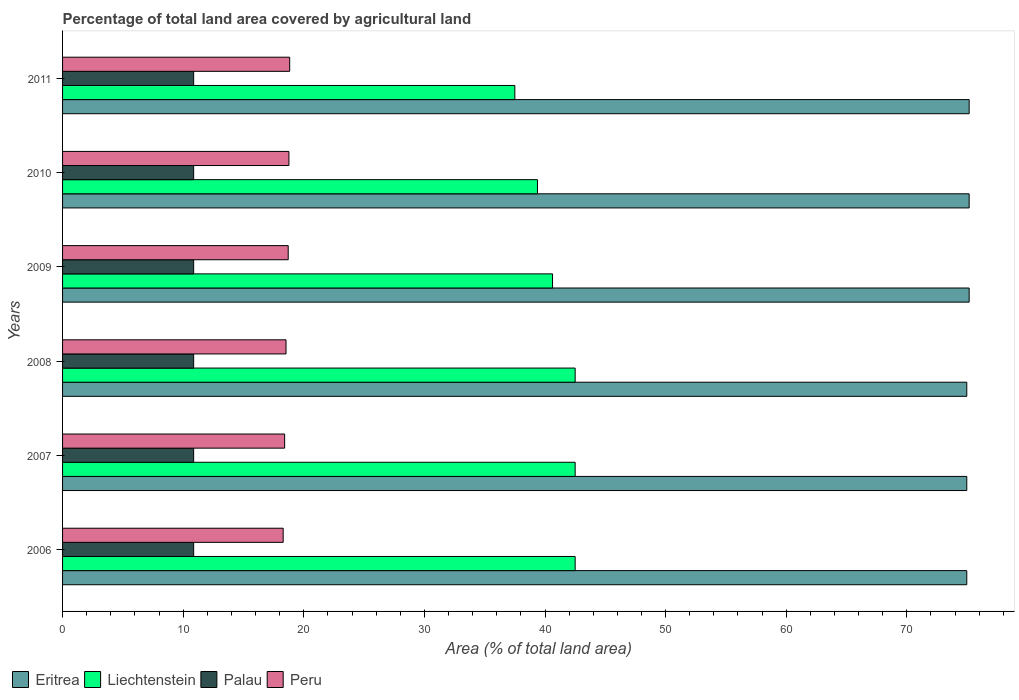Are the number of bars per tick equal to the number of legend labels?
Offer a terse response. Yes. Are the number of bars on each tick of the Y-axis equal?
Keep it short and to the point. Yes. How many bars are there on the 6th tick from the bottom?
Offer a very short reply. 4. What is the label of the 1st group of bars from the top?
Give a very brief answer. 2011. What is the percentage of agricultural land in Peru in 2007?
Provide a succinct answer. 18.41. Across all years, what is the maximum percentage of agricultural land in Eritrea?
Offer a very short reply. 75.17. Across all years, what is the minimum percentage of agricultural land in Peru?
Make the answer very short. 18.29. In which year was the percentage of agricultural land in Palau maximum?
Offer a terse response. 2006. What is the total percentage of agricultural land in Peru in the graph?
Offer a terse response. 111.54. What is the difference between the percentage of agricultural land in Peru in 2006 and that in 2010?
Provide a succinct answer. -0.48. What is the difference between the percentage of agricultural land in Peru in 2010 and the percentage of agricultural land in Palau in 2007?
Provide a succinct answer. 7.9. What is the average percentage of agricultural land in Peru per year?
Provide a succinct answer. 18.59. In the year 2007, what is the difference between the percentage of agricultural land in Eritrea and percentage of agricultural land in Palau?
Make the answer very short. 64.1. What is the ratio of the percentage of agricultural land in Liechtenstein in 2008 to that in 2009?
Ensure brevity in your answer.  1.05. Is the percentage of agricultural land in Peru in 2007 less than that in 2008?
Make the answer very short. Yes. Is the difference between the percentage of agricultural land in Eritrea in 2007 and 2008 greater than the difference between the percentage of agricultural land in Palau in 2007 and 2008?
Give a very brief answer. No. What is the difference between the highest and the second highest percentage of agricultural land in Peru?
Your response must be concise. 0.06. What is the difference between the highest and the lowest percentage of agricultural land in Liechtenstein?
Provide a succinct answer. 5. What does the 1st bar from the top in 2006 represents?
Offer a very short reply. Peru. Are all the bars in the graph horizontal?
Your response must be concise. Yes. How many years are there in the graph?
Offer a terse response. 6. What is the difference between two consecutive major ticks on the X-axis?
Offer a terse response. 10. Does the graph contain any zero values?
Your answer should be compact. No. Does the graph contain grids?
Provide a succinct answer. No. Where does the legend appear in the graph?
Ensure brevity in your answer.  Bottom left. What is the title of the graph?
Your response must be concise. Percentage of total land area covered by agricultural land. What is the label or title of the X-axis?
Keep it short and to the point. Area (% of total land area). What is the label or title of the Y-axis?
Give a very brief answer. Years. What is the Area (% of total land area) of Eritrea in 2006?
Give a very brief answer. 74.97. What is the Area (% of total land area) in Liechtenstein in 2006?
Your answer should be compact. 42.5. What is the Area (% of total land area) of Palau in 2006?
Make the answer very short. 10.87. What is the Area (% of total land area) of Peru in 2006?
Ensure brevity in your answer.  18.29. What is the Area (% of total land area) in Eritrea in 2007?
Your answer should be very brief. 74.97. What is the Area (% of total land area) in Liechtenstein in 2007?
Make the answer very short. 42.5. What is the Area (% of total land area) in Palau in 2007?
Provide a succinct answer. 10.87. What is the Area (% of total land area) of Peru in 2007?
Your answer should be compact. 18.41. What is the Area (% of total land area) in Eritrea in 2008?
Ensure brevity in your answer.  74.97. What is the Area (% of total land area) in Liechtenstein in 2008?
Make the answer very short. 42.5. What is the Area (% of total land area) in Palau in 2008?
Offer a terse response. 10.87. What is the Area (% of total land area) in Peru in 2008?
Keep it short and to the point. 18.53. What is the Area (% of total land area) of Eritrea in 2009?
Provide a short and direct response. 75.17. What is the Area (% of total land area) in Liechtenstein in 2009?
Offer a very short reply. 40.62. What is the Area (% of total land area) in Palau in 2009?
Your response must be concise. 10.87. What is the Area (% of total land area) in Peru in 2009?
Your response must be concise. 18.71. What is the Area (% of total land area) in Eritrea in 2010?
Ensure brevity in your answer.  75.17. What is the Area (% of total land area) in Liechtenstein in 2010?
Your answer should be very brief. 39.38. What is the Area (% of total land area) of Palau in 2010?
Provide a succinct answer. 10.87. What is the Area (% of total land area) of Peru in 2010?
Ensure brevity in your answer.  18.77. What is the Area (% of total land area) of Eritrea in 2011?
Give a very brief answer. 75.17. What is the Area (% of total land area) in Liechtenstein in 2011?
Offer a very short reply. 37.5. What is the Area (% of total land area) of Palau in 2011?
Keep it short and to the point. 10.87. What is the Area (% of total land area) in Peru in 2011?
Give a very brief answer. 18.83. Across all years, what is the maximum Area (% of total land area) in Eritrea?
Offer a terse response. 75.17. Across all years, what is the maximum Area (% of total land area) in Liechtenstein?
Provide a succinct answer. 42.5. Across all years, what is the maximum Area (% of total land area) in Palau?
Provide a short and direct response. 10.87. Across all years, what is the maximum Area (% of total land area) in Peru?
Offer a very short reply. 18.83. Across all years, what is the minimum Area (% of total land area) in Eritrea?
Provide a succinct answer. 74.97. Across all years, what is the minimum Area (% of total land area) in Liechtenstein?
Provide a succinct answer. 37.5. Across all years, what is the minimum Area (% of total land area) in Palau?
Offer a terse response. 10.87. Across all years, what is the minimum Area (% of total land area) in Peru?
Keep it short and to the point. 18.29. What is the total Area (% of total land area) of Eritrea in the graph?
Keep it short and to the point. 450.42. What is the total Area (% of total land area) of Liechtenstein in the graph?
Provide a succinct answer. 245. What is the total Area (% of total land area) of Palau in the graph?
Ensure brevity in your answer.  65.22. What is the total Area (% of total land area) in Peru in the graph?
Offer a terse response. 111.54. What is the difference between the Area (% of total land area) of Eritrea in 2006 and that in 2007?
Keep it short and to the point. 0. What is the difference between the Area (% of total land area) of Peru in 2006 and that in 2007?
Offer a terse response. -0.12. What is the difference between the Area (% of total land area) of Liechtenstein in 2006 and that in 2008?
Make the answer very short. 0. What is the difference between the Area (% of total land area) in Palau in 2006 and that in 2008?
Your answer should be very brief. 0. What is the difference between the Area (% of total land area) of Peru in 2006 and that in 2008?
Ensure brevity in your answer.  -0.24. What is the difference between the Area (% of total land area) of Eritrea in 2006 and that in 2009?
Offer a very short reply. -0.2. What is the difference between the Area (% of total land area) of Liechtenstein in 2006 and that in 2009?
Keep it short and to the point. 1.88. What is the difference between the Area (% of total land area) of Palau in 2006 and that in 2009?
Make the answer very short. 0. What is the difference between the Area (% of total land area) of Peru in 2006 and that in 2009?
Keep it short and to the point. -0.42. What is the difference between the Area (% of total land area) of Eritrea in 2006 and that in 2010?
Your answer should be very brief. -0.2. What is the difference between the Area (% of total land area) in Liechtenstein in 2006 and that in 2010?
Offer a very short reply. 3.12. What is the difference between the Area (% of total land area) of Palau in 2006 and that in 2010?
Your response must be concise. 0. What is the difference between the Area (% of total land area) in Peru in 2006 and that in 2010?
Your answer should be compact. -0.48. What is the difference between the Area (% of total land area) in Eritrea in 2006 and that in 2011?
Make the answer very short. -0.2. What is the difference between the Area (% of total land area) in Palau in 2006 and that in 2011?
Your answer should be compact. 0. What is the difference between the Area (% of total land area) of Peru in 2006 and that in 2011?
Provide a short and direct response. -0.54. What is the difference between the Area (% of total land area) in Liechtenstein in 2007 and that in 2008?
Provide a short and direct response. 0. What is the difference between the Area (% of total land area) of Palau in 2007 and that in 2008?
Offer a very short reply. 0. What is the difference between the Area (% of total land area) in Peru in 2007 and that in 2008?
Offer a very short reply. -0.11. What is the difference between the Area (% of total land area) in Eritrea in 2007 and that in 2009?
Make the answer very short. -0.2. What is the difference between the Area (% of total land area) of Liechtenstein in 2007 and that in 2009?
Your response must be concise. 1.88. What is the difference between the Area (% of total land area) of Peru in 2007 and that in 2009?
Ensure brevity in your answer.  -0.3. What is the difference between the Area (% of total land area) in Eritrea in 2007 and that in 2010?
Offer a terse response. -0.2. What is the difference between the Area (% of total land area) in Liechtenstein in 2007 and that in 2010?
Keep it short and to the point. 3.12. What is the difference between the Area (% of total land area) in Palau in 2007 and that in 2010?
Provide a succinct answer. 0. What is the difference between the Area (% of total land area) in Peru in 2007 and that in 2010?
Offer a terse response. -0.36. What is the difference between the Area (% of total land area) of Eritrea in 2007 and that in 2011?
Your response must be concise. -0.2. What is the difference between the Area (% of total land area) of Liechtenstein in 2007 and that in 2011?
Your answer should be very brief. 5. What is the difference between the Area (% of total land area) in Peru in 2007 and that in 2011?
Your response must be concise. -0.42. What is the difference between the Area (% of total land area) in Eritrea in 2008 and that in 2009?
Your answer should be very brief. -0.2. What is the difference between the Area (% of total land area) of Liechtenstein in 2008 and that in 2009?
Offer a very short reply. 1.88. What is the difference between the Area (% of total land area) of Peru in 2008 and that in 2009?
Provide a short and direct response. -0.18. What is the difference between the Area (% of total land area) in Eritrea in 2008 and that in 2010?
Ensure brevity in your answer.  -0.2. What is the difference between the Area (% of total land area) of Liechtenstein in 2008 and that in 2010?
Offer a terse response. 3.12. What is the difference between the Area (% of total land area) in Palau in 2008 and that in 2010?
Offer a very short reply. 0. What is the difference between the Area (% of total land area) in Peru in 2008 and that in 2010?
Make the answer very short. -0.24. What is the difference between the Area (% of total land area) of Eritrea in 2008 and that in 2011?
Provide a short and direct response. -0.2. What is the difference between the Area (% of total land area) of Liechtenstein in 2008 and that in 2011?
Give a very brief answer. 5. What is the difference between the Area (% of total land area) of Peru in 2008 and that in 2011?
Your response must be concise. -0.3. What is the difference between the Area (% of total land area) of Liechtenstein in 2009 and that in 2010?
Your answer should be compact. 1.25. What is the difference between the Area (% of total land area) in Peru in 2009 and that in 2010?
Keep it short and to the point. -0.06. What is the difference between the Area (% of total land area) of Eritrea in 2009 and that in 2011?
Ensure brevity in your answer.  0. What is the difference between the Area (% of total land area) of Liechtenstein in 2009 and that in 2011?
Keep it short and to the point. 3.12. What is the difference between the Area (% of total land area) of Peru in 2009 and that in 2011?
Offer a very short reply. -0.12. What is the difference between the Area (% of total land area) of Eritrea in 2010 and that in 2011?
Offer a terse response. 0. What is the difference between the Area (% of total land area) in Liechtenstein in 2010 and that in 2011?
Your response must be concise. 1.88. What is the difference between the Area (% of total land area) of Palau in 2010 and that in 2011?
Keep it short and to the point. 0. What is the difference between the Area (% of total land area) in Peru in 2010 and that in 2011?
Your response must be concise. -0.06. What is the difference between the Area (% of total land area) in Eritrea in 2006 and the Area (% of total land area) in Liechtenstein in 2007?
Offer a very short reply. 32.47. What is the difference between the Area (% of total land area) in Eritrea in 2006 and the Area (% of total land area) in Palau in 2007?
Your answer should be compact. 64.1. What is the difference between the Area (% of total land area) in Eritrea in 2006 and the Area (% of total land area) in Peru in 2007?
Your answer should be very brief. 56.56. What is the difference between the Area (% of total land area) in Liechtenstein in 2006 and the Area (% of total land area) in Palau in 2007?
Offer a terse response. 31.63. What is the difference between the Area (% of total land area) of Liechtenstein in 2006 and the Area (% of total land area) of Peru in 2007?
Ensure brevity in your answer.  24.09. What is the difference between the Area (% of total land area) in Palau in 2006 and the Area (% of total land area) in Peru in 2007?
Ensure brevity in your answer.  -7.54. What is the difference between the Area (% of total land area) in Eritrea in 2006 and the Area (% of total land area) in Liechtenstein in 2008?
Offer a very short reply. 32.47. What is the difference between the Area (% of total land area) in Eritrea in 2006 and the Area (% of total land area) in Palau in 2008?
Make the answer very short. 64.1. What is the difference between the Area (% of total land area) in Eritrea in 2006 and the Area (% of total land area) in Peru in 2008?
Your response must be concise. 56.44. What is the difference between the Area (% of total land area) of Liechtenstein in 2006 and the Area (% of total land area) of Palau in 2008?
Your answer should be compact. 31.63. What is the difference between the Area (% of total land area) in Liechtenstein in 2006 and the Area (% of total land area) in Peru in 2008?
Ensure brevity in your answer.  23.97. What is the difference between the Area (% of total land area) of Palau in 2006 and the Area (% of total land area) of Peru in 2008?
Give a very brief answer. -7.66. What is the difference between the Area (% of total land area) of Eritrea in 2006 and the Area (% of total land area) of Liechtenstein in 2009?
Offer a terse response. 34.35. What is the difference between the Area (% of total land area) of Eritrea in 2006 and the Area (% of total land area) of Palau in 2009?
Your response must be concise. 64.1. What is the difference between the Area (% of total land area) of Eritrea in 2006 and the Area (% of total land area) of Peru in 2009?
Provide a short and direct response. 56.26. What is the difference between the Area (% of total land area) of Liechtenstein in 2006 and the Area (% of total land area) of Palau in 2009?
Make the answer very short. 31.63. What is the difference between the Area (% of total land area) in Liechtenstein in 2006 and the Area (% of total land area) in Peru in 2009?
Your response must be concise. 23.79. What is the difference between the Area (% of total land area) in Palau in 2006 and the Area (% of total land area) in Peru in 2009?
Provide a short and direct response. -7.84. What is the difference between the Area (% of total land area) in Eritrea in 2006 and the Area (% of total land area) in Liechtenstein in 2010?
Your answer should be compact. 35.6. What is the difference between the Area (% of total land area) in Eritrea in 2006 and the Area (% of total land area) in Palau in 2010?
Your answer should be compact. 64.1. What is the difference between the Area (% of total land area) of Eritrea in 2006 and the Area (% of total land area) of Peru in 2010?
Your response must be concise. 56.2. What is the difference between the Area (% of total land area) of Liechtenstein in 2006 and the Area (% of total land area) of Palau in 2010?
Your answer should be compact. 31.63. What is the difference between the Area (% of total land area) in Liechtenstein in 2006 and the Area (% of total land area) in Peru in 2010?
Offer a very short reply. 23.73. What is the difference between the Area (% of total land area) in Palau in 2006 and the Area (% of total land area) in Peru in 2010?
Make the answer very short. -7.9. What is the difference between the Area (% of total land area) in Eritrea in 2006 and the Area (% of total land area) in Liechtenstein in 2011?
Your response must be concise. 37.47. What is the difference between the Area (% of total land area) of Eritrea in 2006 and the Area (% of total land area) of Palau in 2011?
Offer a very short reply. 64.1. What is the difference between the Area (% of total land area) of Eritrea in 2006 and the Area (% of total land area) of Peru in 2011?
Provide a short and direct response. 56.14. What is the difference between the Area (% of total land area) in Liechtenstein in 2006 and the Area (% of total land area) in Palau in 2011?
Your response must be concise. 31.63. What is the difference between the Area (% of total land area) of Liechtenstein in 2006 and the Area (% of total land area) of Peru in 2011?
Give a very brief answer. 23.67. What is the difference between the Area (% of total land area) of Palau in 2006 and the Area (% of total land area) of Peru in 2011?
Provide a short and direct response. -7.96. What is the difference between the Area (% of total land area) in Eritrea in 2007 and the Area (% of total land area) in Liechtenstein in 2008?
Make the answer very short. 32.47. What is the difference between the Area (% of total land area) in Eritrea in 2007 and the Area (% of total land area) in Palau in 2008?
Your response must be concise. 64.1. What is the difference between the Area (% of total land area) of Eritrea in 2007 and the Area (% of total land area) of Peru in 2008?
Make the answer very short. 56.44. What is the difference between the Area (% of total land area) in Liechtenstein in 2007 and the Area (% of total land area) in Palau in 2008?
Your response must be concise. 31.63. What is the difference between the Area (% of total land area) in Liechtenstein in 2007 and the Area (% of total land area) in Peru in 2008?
Your answer should be compact. 23.97. What is the difference between the Area (% of total land area) of Palau in 2007 and the Area (% of total land area) of Peru in 2008?
Offer a very short reply. -7.66. What is the difference between the Area (% of total land area) of Eritrea in 2007 and the Area (% of total land area) of Liechtenstein in 2009?
Ensure brevity in your answer.  34.35. What is the difference between the Area (% of total land area) in Eritrea in 2007 and the Area (% of total land area) in Palau in 2009?
Ensure brevity in your answer.  64.1. What is the difference between the Area (% of total land area) in Eritrea in 2007 and the Area (% of total land area) in Peru in 2009?
Give a very brief answer. 56.26. What is the difference between the Area (% of total land area) of Liechtenstein in 2007 and the Area (% of total land area) of Palau in 2009?
Your answer should be very brief. 31.63. What is the difference between the Area (% of total land area) of Liechtenstein in 2007 and the Area (% of total land area) of Peru in 2009?
Provide a short and direct response. 23.79. What is the difference between the Area (% of total land area) of Palau in 2007 and the Area (% of total land area) of Peru in 2009?
Your answer should be very brief. -7.84. What is the difference between the Area (% of total land area) of Eritrea in 2007 and the Area (% of total land area) of Liechtenstein in 2010?
Your answer should be compact. 35.6. What is the difference between the Area (% of total land area) of Eritrea in 2007 and the Area (% of total land area) of Palau in 2010?
Keep it short and to the point. 64.1. What is the difference between the Area (% of total land area) in Eritrea in 2007 and the Area (% of total land area) in Peru in 2010?
Provide a short and direct response. 56.2. What is the difference between the Area (% of total land area) of Liechtenstein in 2007 and the Area (% of total land area) of Palau in 2010?
Give a very brief answer. 31.63. What is the difference between the Area (% of total land area) of Liechtenstein in 2007 and the Area (% of total land area) of Peru in 2010?
Provide a short and direct response. 23.73. What is the difference between the Area (% of total land area) in Palau in 2007 and the Area (% of total land area) in Peru in 2010?
Your answer should be very brief. -7.9. What is the difference between the Area (% of total land area) in Eritrea in 2007 and the Area (% of total land area) in Liechtenstein in 2011?
Provide a short and direct response. 37.47. What is the difference between the Area (% of total land area) in Eritrea in 2007 and the Area (% of total land area) in Palau in 2011?
Make the answer very short. 64.1. What is the difference between the Area (% of total land area) of Eritrea in 2007 and the Area (% of total land area) of Peru in 2011?
Your answer should be compact. 56.14. What is the difference between the Area (% of total land area) in Liechtenstein in 2007 and the Area (% of total land area) in Palau in 2011?
Ensure brevity in your answer.  31.63. What is the difference between the Area (% of total land area) in Liechtenstein in 2007 and the Area (% of total land area) in Peru in 2011?
Provide a succinct answer. 23.67. What is the difference between the Area (% of total land area) in Palau in 2007 and the Area (% of total land area) in Peru in 2011?
Offer a very short reply. -7.96. What is the difference between the Area (% of total land area) of Eritrea in 2008 and the Area (% of total land area) of Liechtenstein in 2009?
Make the answer very short. 34.35. What is the difference between the Area (% of total land area) in Eritrea in 2008 and the Area (% of total land area) in Palau in 2009?
Offer a very short reply. 64.1. What is the difference between the Area (% of total land area) of Eritrea in 2008 and the Area (% of total land area) of Peru in 2009?
Keep it short and to the point. 56.26. What is the difference between the Area (% of total land area) of Liechtenstein in 2008 and the Area (% of total land area) of Palau in 2009?
Keep it short and to the point. 31.63. What is the difference between the Area (% of total land area) in Liechtenstein in 2008 and the Area (% of total land area) in Peru in 2009?
Make the answer very short. 23.79. What is the difference between the Area (% of total land area) in Palau in 2008 and the Area (% of total land area) in Peru in 2009?
Offer a very short reply. -7.84. What is the difference between the Area (% of total land area) in Eritrea in 2008 and the Area (% of total land area) in Liechtenstein in 2010?
Make the answer very short. 35.6. What is the difference between the Area (% of total land area) of Eritrea in 2008 and the Area (% of total land area) of Palau in 2010?
Make the answer very short. 64.1. What is the difference between the Area (% of total land area) of Eritrea in 2008 and the Area (% of total land area) of Peru in 2010?
Your response must be concise. 56.2. What is the difference between the Area (% of total land area) of Liechtenstein in 2008 and the Area (% of total land area) of Palau in 2010?
Provide a succinct answer. 31.63. What is the difference between the Area (% of total land area) of Liechtenstein in 2008 and the Area (% of total land area) of Peru in 2010?
Give a very brief answer. 23.73. What is the difference between the Area (% of total land area) in Palau in 2008 and the Area (% of total land area) in Peru in 2010?
Make the answer very short. -7.9. What is the difference between the Area (% of total land area) in Eritrea in 2008 and the Area (% of total land area) in Liechtenstein in 2011?
Provide a succinct answer. 37.47. What is the difference between the Area (% of total land area) of Eritrea in 2008 and the Area (% of total land area) of Palau in 2011?
Your answer should be very brief. 64.1. What is the difference between the Area (% of total land area) in Eritrea in 2008 and the Area (% of total land area) in Peru in 2011?
Your response must be concise. 56.14. What is the difference between the Area (% of total land area) in Liechtenstein in 2008 and the Area (% of total land area) in Palau in 2011?
Your answer should be very brief. 31.63. What is the difference between the Area (% of total land area) of Liechtenstein in 2008 and the Area (% of total land area) of Peru in 2011?
Your answer should be very brief. 23.67. What is the difference between the Area (% of total land area) in Palau in 2008 and the Area (% of total land area) in Peru in 2011?
Offer a terse response. -7.96. What is the difference between the Area (% of total land area) in Eritrea in 2009 and the Area (% of total land area) in Liechtenstein in 2010?
Give a very brief answer. 35.79. What is the difference between the Area (% of total land area) of Eritrea in 2009 and the Area (% of total land area) of Palau in 2010?
Make the answer very short. 64.3. What is the difference between the Area (% of total land area) in Eritrea in 2009 and the Area (% of total land area) in Peru in 2010?
Your answer should be very brief. 56.4. What is the difference between the Area (% of total land area) in Liechtenstein in 2009 and the Area (% of total land area) in Palau in 2010?
Your answer should be compact. 29.76. What is the difference between the Area (% of total land area) in Liechtenstein in 2009 and the Area (% of total land area) in Peru in 2010?
Your response must be concise. 21.86. What is the difference between the Area (% of total land area) of Palau in 2009 and the Area (% of total land area) of Peru in 2010?
Offer a terse response. -7.9. What is the difference between the Area (% of total land area) of Eritrea in 2009 and the Area (% of total land area) of Liechtenstein in 2011?
Provide a short and direct response. 37.67. What is the difference between the Area (% of total land area) in Eritrea in 2009 and the Area (% of total land area) in Palau in 2011?
Your answer should be very brief. 64.3. What is the difference between the Area (% of total land area) of Eritrea in 2009 and the Area (% of total land area) of Peru in 2011?
Provide a succinct answer. 56.34. What is the difference between the Area (% of total land area) of Liechtenstein in 2009 and the Area (% of total land area) of Palau in 2011?
Offer a terse response. 29.76. What is the difference between the Area (% of total land area) in Liechtenstein in 2009 and the Area (% of total land area) in Peru in 2011?
Ensure brevity in your answer.  21.79. What is the difference between the Area (% of total land area) of Palau in 2009 and the Area (% of total land area) of Peru in 2011?
Give a very brief answer. -7.96. What is the difference between the Area (% of total land area) of Eritrea in 2010 and the Area (% of total land area) of Liechtenstein in 2011?
Provide a succinct answer. 37.67. What is the difference between the Area (% of total land area) of Eritrea in 2010 and the Area (% of total land area) of Palau in 2011?
Offer a terse response. 64.3. What is the difference between the Area (% of total land area) in Eritrea in 2010 and the Area (% of total land area) in Peru in 2011?
Your answer should be very brief. 56.34. What is the difference between the Area (% of total land area) in Liechtenstein in 2010 and the Area (% of total land area) in Palau in 2011?
Your response must be concise. 28.51. What is the difference between the Area (% of total land area) in Liechtenstein in 2010 and the Area (% of total land area) in Peru in 2011?
Provide a succinct answer. 20.54. What is the difference between the Area (% of total land area) of Palau in 2010 and the Area (% of total land area) of Peru in 2011?
Keep it short and to the point. -7.96. What is the average Area (% of total land area) of Eritrea per year?
Your answer should be very brief. 75.07. What is the average Area (% of total land area) in Liechtenstein per year?
Your answer should be very brief. 40.83. What is the average Area (% of total land area) in Palau per year?
Provide a short and direct response. 10.87. What is the average Area (% of total land area) of Peru per year?
Your answer should be very brief. 18.59. In the year 2006, what is the difference between the Area (% of total land area) in Eritrea and Area (% of total land area) in Liechtenstein?
Offer a very short reply. 32.47. In the year 2006, what is the difference between the Area (% of total land area) in Eritrea and Area (% of total land area) in Palau?
Give a very brief answer. 64.1. In the year 2006, what is the difference between the Area (% of total land area) of Eritrea and Area (% of total land area) of Peru?
Provide a succinct answer. 56.68. In the year 2006, what is the difference between the Area (% of total land area) in Liechtenstein and Area (% of total land area) in Palau?
Make the answer very short. 31.63. In the year 2006, what is the difference between the Area (% of total land area) of Liechtenstein and Area (% of total land area) of Peru?
Your answer should be very brief. 24.21. In the year 2006, what is the difference between the Area (% of total land area) of Palau and Area (% of total land area) of Peru?
Offer a very short reply. -7.42. In the year 2007, what is the difference between the Area (% of total land area) of Eritrea and Area (% of total land area) of Liechtenstein?
Offer a very short reply. 32.47. In the year 2007, what is the difference between the Area (% of total land area) in Eritrea and Area (% of total land area) in Palau?
Your answer should be very brief. 64.1. In the year 2007, what is the difference between the Area (% of total land area) of Eritrea and Area (% of total land area) of Peru?
Your response must be concise. 56.56. In the year 2007, what is the difference between the Area (% of total land area) in Liechtenstein and Area (% of total land area) in Palau?
Make the answer very short. 31.63. In the year 2007, what is the difference between the Area (% of total land area) in Liechtenstein and Area (% of total land area) in Peru?
Your answer should be compact. 24.09. In the year 2007, what is the difference between the Area (% of total land area) in Palau and Area (% of total land area) in Peru?
Offer a very short reply. -7.54. In the year 2008, what is the difference between the Area (% of total land area) of Eritrea and Area (% of total land area) of Liechtenstein?
Provide a succinct answer. 32.47. In the year 2008, what is the difference between the Area (% of total land area) of Eritrea and Area (% of total land area) of Palau?
Make the answer very short. 64.1. In the year 2008, what is the difference between the Area (% of total land area) of Eritrea and Area (% of total land area) of Peru?
Ensure brevity in your answer.  56.44. In the year 2008, what is the difference between the Area (% of total land area) of Liechtenstein and Area (% of total land area) of Palau?
Your answer should be very brief. 31.63. In the year 2008, what is the difference between the Area (% of total land area) in Liechtenstein and Area (% of total land area) in Peru?
Provide a short and direct response. 23.97. In the year 2008, what is the difference between the Area (% of total land area) in Palau and Area (% of total land area) in Peru?
Keep it short and to the point. -7.66. In the year 2009, what is the difference between the Area (% of total land area) of Eritrea and Area (% of total land area) of Liechtenstein?
Provide a short and direct response. 34.54. In the year 2009, what is the difference between the Area (% of total land area) of Eritrea and Area (% of total land area) of Palau?
Provide a succinct answer. 64.3. In the year 2009, what is the difference between the Area (% of total land area) of Eritrea and Area (% of total land area) of Peru?
Provide a short and direct response. 56.46. In the year 2009, what is the difference between the Area (% of total land area) in Liechtenstein and Area (% of total land area) in Palau?
Provide a succinct answer. 29.76. In the year 2009, what is the difference between the Area (% of total land area) in Liechtenstein and Area (% of total land area) in Peru?
Keep it short and to the point. 21.92. In the year 2009, what is the difference between the Area (% of total land area) in Palau and Area (% of total land area) in Peru?
Provide a succinct answer. -7.84. In the year 2010, what is the difference between the Area (% of total land area) in Eritrea and Area (% of total land area) in Liechtenstein?
Make the answer very short. 35.79. In the year 2010, what is the difference between the Area (% of total land area) of Eritrea and Area (% of total land area) of Palau?
Your answer should be compact. 64.3. In the year 2010, what is the difference between the Area (% of total land area) of Eritrea and Area (% of total land area) of Peru?
Offer a terse response. 56.4. In the year 2010, what is the difference between the Area (% of total land area) of Liechtenstein and Area (% of total land area) of Palau?
Offer a terse response. 28.51. In the year 2010, what is the difference between the Area (% of total land area) of Liechtenstein and Area (% of total land area) of Peru?
Provide a short and direct response. 20.61. In the year 2010, what is the difference between the Area (% of total land area) of Palau and Area (% of total land area) of Peru?
Keep it short and to the point. -7.9. In the year 2011, what is the difference between the Area (% of total land area) in Eritrea and Area (% of total land area) in Liechtenstein?
Provide a succinct answer. 37.67. In the year 2011, what is the difference between the Area (% of total land area) of Eritrea and Area (% of total land area) of Palau?
Give a very brief answer. 64.3. In the year 2011, what is the difference between the Area (% of total land area) in Eritrea and Area (% of total land area) in Peru?
Give a very brief answer. 56.34. In the year 2011, what is the difference between the Area (% of total land area) of Liechtenstein and Area (% of total land area) of Palau?
Make the answer very short. 26.63. In the year 2011, what is the difference between the Area (% of total land area) of Liechtenstein and Area (% of total land area) of Peru?
Ensure brevity in your answer.  18.67. In the year 2011, what is the difference between the Area (% of total land area) in Palau and Area (% of total land area) in Peru?
Provide a short and direct response. -7.96. What is the ratio of the Area (% of total land area) of Eritrea in 2006 to that in 2007?
Your answer should be very brief. 1. What is the ratio of the Area (% of total land area) of Liechtenstein in 2006 to that in 2007?
Make the answer very short. 1. What is the ratio of the Area (% of total land area) in Palau in 2006 to that in 2007?
Offer a very short reply. 1. What is the ratio of the Area (% of total land area) in Peru in 2006 to that in 2007?
Offer a terse response. 0.99. What is the ratio of the Area (% of total land area) in Eritrea in 2006 to that in 2008?
Make the answer very short. 1. What is the ratio of the Area (% of total land area) of Palau in 2006 to that in 2008?
Your response must be concise. 1. What is the ratio of the Area (% of total land area) in Peru in 2006 to that in 2008?
Give a very brief answer. 0.99. What is the ratio of the Area (% of total land area) of Eritrea in 2006 to that in 2009?
Your answer should be very brief. 1. What is the ratio of the Area (% of total land area) of Liechtenstein in 2006 to that in 2009?
Ensure brevity in your answer.  1.05. What is the ratio of the Area (% of total land area) in Peru in 2006 to that in 2009?
Your response must be concise. 0.98. What is the ratio of the Area (% of total land area) in Eritrea in 2006 to that in 2010?
Offer a terse response. 1. What is the ratio of the Area (% of total land area) in Liechtenstein in 2006 to that in 2010?
Keep it short and to the point. 1.08. What is the ratio of the Area (% of total land area) of Palau in 2006 to that in 2010?
Offer a terse response. 1. What is the ratio of the Area (% of total land area) of Peru in 2006 to that in 2010?
Provide a succinct answer. 0.97. What is the ratio of the Area (% of total land area) of Liechtenstein in 2006 to that in 2011?
Provide a short and direct response. 1.13. What is the ratio of the Area (% of total land area) of Palau in 2006 to that in 2011?
Your response must be concise. 1. What is the ratio of the Area (% of total land area) of Peru in 2006 to that in 2011?
Your response must be concise. 0.97. What is the ratio of the Area (% of total land area) of Liechtenstein in 2007 to that in 2008?
Your answer should be compact. 1. What is the ratio of the Area (% of total land area) in Peru in 2007 to that in 2008?
Offer a very short reply. 0.99. What is the ratio of the Area (% of total land area) of Eritrea in 2007 to that in 2009?
Your response must be concise. 1. What is the ratio of the Area (% of total land area) in Liechtenstein in 2007 to that in 2009?
Give a very brief answer. 1.05. What is the ratio of the Area (% of total land area) in Palau in 2007 to that in 2009?
Make the answer very short. 1. What is the ratio of the Area (% of total land area) in Peru in 2007 to that in 2009?
Offer a terse response. 0.98. What is the ratio of the Area (% of total land area) of Eritrea in 2007 to that in 2010?
Keep it short and to the point. 1. What is the ratio of the Area (% of total land area) in Liechtenstein in 2007 to that in 2010?
Offer a terse response. 1.08. What is the ratio of the Area (% of total land area) of Palau in 2007 to that in 2010?
Offer a very short reply. 1. What is the ratio of the Area (% of total land area) in Peru in 2007 to that in 2010?
Offer a terse response. 0.98. What is the ratio of the Area (% of total land area) of Eritrea in 2007 to that in 2011?
Your answer should be compact. 1. What is the ratio of the Area (% of total land area) in Liechtenstein in 2007 to that in 2011?
Offer a terse response. 1.13. What is the ratio of the Area (% of total land area) in Palau in 2007 to that in 2011?
Keep it short and to the point. 1. What is the ratio of the Area (% of total land area) in Peru in 2007 to that in 2011?
Keep it short and to the point. 0.98. What is the ratio of the Area (% of total land area) of Eritrea in 2008 to that in 2009?
Make the answer very short. 1. What is the ratio of the Area (% of total land area) in Liechtenstein in 2008 to that in 2009?
Provide a short and direct response. 1.05. What is the ratio of the Area (% of total land area) in Palau in 2008 to that in 2009?
Provide a succinct answer. 1. What is the ratio of the Area (% of total land area) of Peru in 2008 to that in 2009?
Give a very brief answer. 0.99. What is the ratio of the Area (% of total land area) in Liechtenstein in 2008 to that in 2010?
Your answer should be very brief. 1.08. What is the ratio of the Area (% of total land area) in Palau in 2008 to that in 2010?
Offer a terse response. 1. What is the ratio of the Area (% of total land area) of Peru in 2008 to that in 2010?
Your answer should be very brief. 0.99. What is the ratio of the Area (% of total land area) in Eritrea in 2008 to that in 2011?
Your response must be concise. 1. What is the ratio of the Area (% of total land area) of Liechtenstein in 2008 to that in 2011?
Keep it short and to the point. 1.13. What is the ratio of the Area (% of total land area) in Palau in 2008 to that in 2011?
Offer a terse response. 1. What is the ratio of the Area (% of total land area) of Peru in 2008 to that in 2011?
Your response must be concise. 0.98. What is the ratio of the Area (% of total land area) of Liechtenstein in 2009 to that in 2010?
Your answer should be very brief. 1.03. What is the ratio of the Area (% of total land area) of Palau in 2009 to that in 2010?
Your answer should be very brief. 1. What is the ratio of the Area (% of total land area) in Eritrea in 2009 to that in 2011?
Make the answer very short. 1. What is the ratio of the Area (% of total land area) of Liechtenstein in 2009 to that in 2011?
Your answer should be compact. 1.08. What is the ratio of the Area (% of total land area) in Palau in 2009 to that in 2011?
Provide a succinct answer. 1. What is the ratio of the Area (% of total land area) in Peru in 2009 to that in 2011?
Make the answer very short. 0.99. What is the ratio of the Area (% of total land area) of Eritrea in 2010 to that in 2011?
Make the answer very short. 1. What is the ratio of the Area (% of total land area) in Palau in 2010 to that in 2011?
Provide a succinct answer. 1. What is the ratio of the Area (% of total land area) of Peru in 2010 to that in 2011?
Ensure brevity in your answer.  1. What is the difference between the highest and the second highest Area (% of total land area) of Liechtenstein?
Make the answer very short. 0. What is the difference between the highest and the second highest Area (% of total land area) in Peru?
Your answer should be very brief. 0.06. What is the difference between the highest and the lowest Area (% of total land area) of Eritrea?
Give a very brief answer. 0.2. What is the difference between the highest and the lowest Area (% of total land area) in Liechtenstein?
Give a very brief answer. 5. What is the difference between the highest and the lowest Area (% of total land area) in Palau?
Provide a succinct answer. 0. What is the difference between the highest and the lowest Area (% of total land area) in Peru?
Provide a short and direct response. 0.54. 